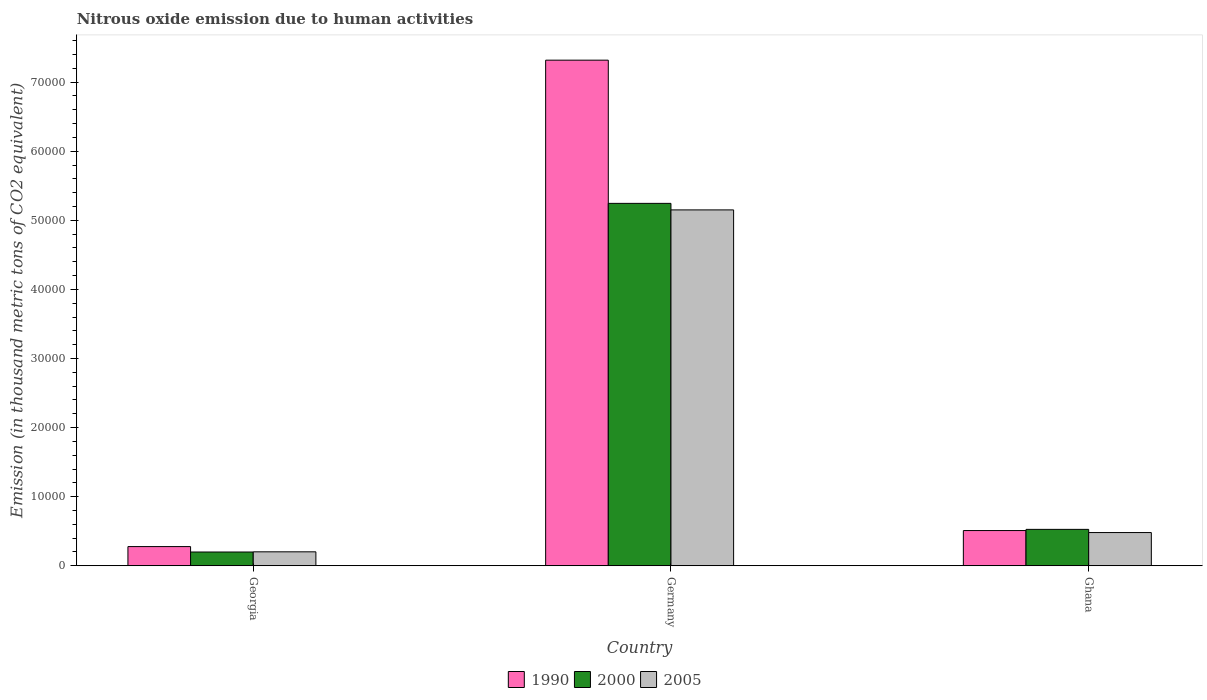How many different coloured bars are there?
Keep it short and to the point. 3. How many groups of bars are there?
Make the answer very short. 3. What is the label of the 1st group of bars from the left?
Your answer should be compact. Georgia. What is the amount of nitrous oxide emitted in 1990 in Germany?
Make the answer very short. 7.32e+04. Across all countries, what is the maximum amount of nitrous oxide emitted in 1990?
Provide a succinct answer. 7.32e+04. Across all countries, what is the minimum amount of nitrous oxide emitted in 2000?
Make the answer very short. 1994.5. In which country was the amount of nitrous oxide emitted in 2005 minimum?
Make the answer very short. Georgia. What is the total amount of nitrous oxide emitted in 2000 in the graph?
Offer a very short reply. 5.97e+04. What is the difference between the amount of nitrous oxide emitted in 1990 in Georgia and that in Germany?
Your response must be concise. -7.04e+04. What is the difference between the amount of nitrous oxide emitted in 2005 in Georgia and the amount of nitrous oxide emitted in 1990 in Germany?
Ensure brevity in your answer.  -7.12e+04. What is the average amount of nitrous oxide emitted in 1990 per country?
Offer a very short reply. 2.70e+04. What is the difference between the amount of nitrous oxide emitted of/in 2000 and amount of nitrous oxide emitted of/in 1990 in Ghana?
Offer a very short reply. 170. In how many countries, is the amount of nitrous oxide emitted in 2005 greater than 6000 thousand metric tons?
Offer a very short reply. 1. What is the ratio of the amount of nitrous oxide emitted in 2005 in Georgia to that in Ghana?
Your answer should be compact. 0.42. Is the amount of nitrous oxide emitted in 2005 in Georgia less than that in Ghana?
Offer a terse response. Yes. What is the difference between the highest and the second highest amount of nitrous oxide emitted in 2005?
Your answer should be compact. 4.67e+04. What is the difference between the highest and the lowest amount of nitrous oxide emitted in 2000?
Your response must be concise. 5.05e+04. Is the sum of the amount of nitrous oxide emitted in 2000 in Georgia and Ghana greater than the maximum amount of nitrous oxide emitted in 1990 across all countries?
Provide a succinct answer. No. What does the 1st bar from the right in Georgia represents?
Provide a succinct answer. 2005. Are all the bars in the graph horizontal?
Make the answer very short. No. Are the values on the major ticks of Y-axis written in scientific E-notation?
Your answer should be compact. No. Does the graph contain any zero values?
Offer a very short reply. No. Does the graph contain grids?
Keep it short and to the point. No. Where does the legend appear in the graph?
Provide a short and direct response. Bottom center. What is the title of the graph?
Give a very brief answer. Nitrous oxide emission due to human activities. What is the label or title of the X-axis?
Offer a very short reply. Country. What is the label or title of the Y-axis?
Your answer should be very brief. Emission (in thousand metric tons of CO2 equivalent). What is the Emission (in thousand metric tons of CO2 equivalent) in 1990 in Georgia?
Your answer should be compact. 2780.8. What is the Emission (in thousand metric tons of CO2 equivalent) of 2000 in Georgia?
Keep it short and to the point. 1994.5. What is the Emission (in thousand metric tons of CO2 equivalent) of 2005 in Georgia?
Provide a short and direct response. 2022. What is the Emission (in thousand metric tons of CO2 equivalent) of 1990 in Germany?
Your answer should be compact. 7.32e+04. What is the Emission (in thousand metric tons of CO2 equivalent) of 2000 in Germany?
Your answer should be compact. 5.25e+04. What is the Emission (in thousand metric tons of CO2 equivalent) in 2005 in Germany?
Offer a very short reply. 5.15e+04. What is the Emission (in thousand metric tons of CO2 equivalent) of 1990 in Ghana?
Your answer should be very brief. 5101.4. What is the Emission (in thousand metric tons of CO2 equivalent) in 2000 in Ghana?
Make the answer very short. 5271.4. What is the Emission (in thousand metric tons of CO2 equivalent) in 2005 in Ghana?
Give a very brief answer. 4812. Across all countries, what is the maximum Emission (in thousand metric tons of CO2 equivalent) of 1990?
Ensure brevity in your answer.  7.32e+04. Across all countries, what is the maximum Emission (in thousand metric tons of CO2 equivalent) in 2000?
Your response must be concise. 5.25e+04. Across all countries, what is the maximum Emission (in thousand metric tons of CO2 equivalent) of 2005?
Your answer should be very brief. 5.15e+04. Across all countries, what is the minimum Emission (in thousand metric tons of CO2 equivalent) in 1990?
Your response must be concise. 2780.8. Across all countries, what is the minimum Emission (in thousand metric tons of CO2 equivalent) in 2000?
Provide a succinct answer. 1994.5. Across all countries, what is the minimum Emission (in thousand metric tons of CO2 equivalent) of 2005?
Ensure brevity in your answer.  2022. What is the total Emission (in thousand metric tons of CO2 equivalent) of 1990 in the graph?
Provide a succinct answer. 8.11e+04. What is the total Emission (in thousand metric tons of CO2 equivalent) of 2000 in the graph?
Provide a short and direct response. 5.97e+04. What is the total Emission (in thousand metric tons of CO2 equivalent) of 2005 in the graph?
Your answer should be compact. 5.83e+04. What is the difference between the Emission (in thousand metric tons of CO2 equivalent) of 1990 in Georgia and that in Germany?
Keep it short and to the point. -7.04e+04. What is the difference between the Emission (in thousand metric tons of CO2 equivalent) in 2000 in Georgia and that in Germany?
Give a very brief answer. -5.05e+04. What is the difference between the Emission (in thousand metric tons of CO2 equivalent) in 2005 in Georgia and that in Germany?
Give a very brief answer. -4.95e+04. What is the difference between the Emission (in thousand metric tons of CO2 equivalent) in 1990 in Georgia and that in Ghana?
Ensure brevity in your answer.  -2320.6. What is the difference between the Emission (in thousand metric tons of CO2 equivalent) of 2000 in Georgia and that in Ghana?
Provide a short and direct response. -3276.9. What is the difference between the Emission (in thousand metric tons of CO2 equivalent) in 2005 in Georgia and that in Ghana?
Provide a short and direct response. -2790. What is the difference between the Emission (in thousand metric tons of CO2 equivalent) in 1990 in Germany and that in Ghana?
Provide a short and direct response. 6.81e+04. What is the difference between the Emission (in thousand metric tons of CO2 equivalent) in 2000 in Germany and that in Ghana?
Provide a short and direct response. 4.72e+04. What is the difference between the Emission (in thousand metric tons of CO2 equivalent) in 2005 in Germany and that in Ghana?
Offer a terse response. 4.67e+04. What is the difference between the Emission (in thousand metric tons of CO2 equivalent) of 1990 in Georgia and the Emission (in thousand metric tons of CO2 equivalent) of 2000 in Germany?
Keep it short and to the point. -4.97e+04. What is the difference between the Emission (in thousand metric tons of CO2 equivalent) in 1990 in Georgia and the Emission (in thousand metric tons of CO2 equivalent) in 2005 in Germany?
Your answer should be very brief. -4.87e+04. What is the difference between the Emission (in thousand metric tons of CO2 equivalent) of 2000 in Georgia and the Emission (in thousand metric tons of CO2 equivalent) of 2005 in Germany?
Provide a succinct answer. -4.95e+04. What is the difference between the Emission (in thousand metric tons of CO2 equivalent) in 1990 in Georgia and the Emission (in thousand metric tons of CO2 equivalent) in 2000 in Ghana?
Your response must be concise. -2490.6. What is the difference between the Emission (in thousand metric tons of CO2 equivalent) of 1990 in Georgia and the Emission (in thousand metric tons of CO2 equivalent) of 2005 in Ghana?
Offer a terse response. -2031.2. What is the difference between the Emission (in thousand metric tons of CO2 equivalent) in 2000 in Georgia and the Emission (in thousand metric tons of CO2 equivalent) in 2005 in Ghana?
Your answer should be compact. -2817.5. What is the difference between the Emission (in thousand metric tons of CO2 equivalent) in 1990 in Germany and the Emission (in thousand metric tons of CO2 equivalent) in 2000 in Ghana?
Your response must be concise. 6.79e+04. What is the difference between the Emission (in thousand metric tons of CO2 equivalent) in 1990 in Germany and the Emission (in thousand metric tons of CO2 equivalent) in 2005 in Ghana?
Make the answer very short. 6.84e+04. What is the difference between the Emission (in thousand metric tons of CO2 equivalent) in 2000 in Germany and the Emission (in thousand metric tons of CO2 equivalent) in 2005 in Ghana?
Your answer should be very brief. 4.76e+04. What is the average Emission (in thousand metric tons of CO2 equivalent) of 1990 per country?
Your answer should be compact. 2.70e+04. What is the average Emission (in thousand metric tons of CO2 equivalent) of 2000 per country?
Provide a short and direct response. 1.99e+04. What is the average Emission (in thousand metric tons of CO2 equivalent) of 2005 per country?
Give a very brief answer. 1.94e+04. What is the difference between the Emission (in thousand metric tons of CO2 equivalent) in 1990 and Emission (in thousand metric tons of CO2 equivalent) in 2000 in Georgia?
Offer a very short reply. 786.3. What is the difference between the Emission (in thousand metric tons of CO2 equivalent) in 1990 and Emission (in thousand metric tons of CO2 equivalent) in 2005 in Georgia?
Make the answer very short. 758.8. What is the difference between the Emission (in thousand metric tons of CO2 equivalent) of 2000 and Emission (in thousand metric tons of CO2 equivalent) of 2005 in Georgia?
Your answer should be very brief. -27.5. What is the difference between the Emission (in thousand metric tons of CO2 equivalent) in 1990 and Emission (in thousand metric tons of CO2 equivalent) in 2000 in Germany?
Offer a terse response. 2.07e+04. What is the difference between the Emission (in thousand metric tons of CO2 equivalent) in 1990 and Emission (in thousand metric tons of CO2 equivalent) in 2005 in Germany?
Provide a short and direct response. 2.17e+04. What is the difference between the Emission (in thousand metric tons of CO2 equivalent) in 2000 and Emission (in thousand metric tons of CO2 equivalent) in 2005 in Germany?
Make the answer very short. 945.2. What is the difference between the Emission (in thousand metric tons of CO2 equivalent) of 1990 and Emission (in thousand metric tons of CO2 equivalent) of 2000 in Ghana?
Ensure brevity in your answer.  -170. What is the difference between the Emission (in thousand metric tons of CO2 equivalent) of 1990 and Emission (in thousand metric tons of CO2 equivalent) of 2005 in Ghana?
Make the answer very short. 289.4. What is the difference between the Emission (in thousand metric tons of CO2 equivalent) in 2000 and Emission (in thousand metric tons of CO2 equivalent) in 2005 in Ghana?
Make the answer very short. 459.4. What is the ratio of the Emission (in thousand metric tons of CO2 equivalent) in 1990 in Georgia to that in Germany?
Offer a terse response. 0.04. What is the ratio of the Emission (in thousand metric tons of CO2 equivalent) in 2000 in Georgia to that in Germany?
Make the answer very short. 0.04. What is the ratio of the Emission (in thousand metric tons of CO2 equivalent) of 2005 in Georgia to that in Germany?
Provide a succinct answer. 0.04. What is the ratio of the Emission (in thousand metric tons of CO2 equivalent) of 1990 in Georgia to that in Ghana?
Your answer should be very brief. 0.55. What is the ratio of the Emission (in thousand metric tons of CO2 equivalent) of 2000 in Georgia to that in Ghana?
Keep it short and to the point. 0.38. What is the ratio of the Emission (in thousand metric tons of CO2 equivalent) of 2005 in Georgia to that in Ghana?
Your response must be concise. 0.42. What is the ratio of the Emission (in thousand metric tons of CO2 equivalent) of 1990 in Germany to that in Ghana?
Offer a terse response. 14.35. What is the ratio of the Emission (in thousand metric tons of CO2 equivalent) of 2000 in Germany to that in Ghana?
Give a very brief answer. 9.95. What is the ratio of the Emission (in thousand metric tons of CO2 equivalent) of 2005 in Germany to that in Ghana?
Ensure brevity in your answer.  10.71. What is the difference between the highest and the second highest Emission (in thousand metric tons of CO2 equivalent) of 1990?
Provide a succinct answer. 6.81e+04. What is the difference between the highest and the second highest Emission (in thousand metric tons of CO2 equivalent) of 2000?
Your answer should be compact. 4.72e+04. What is the difference between the highest and the second highest Emission (in thousand metric tons of CO2 equivalent) of 2005?
Make the answer very short. 4.67e+04. What is the difference between the highest and the lowest Emission (in thousand metric tons of CO2 equivalent) in 1990?
Make the answer very short. 7.04e+04. What is the difference between the highest and the lowest Emission (in thousand metric tons of CO2 equivalent) of 2000?
Provide a short and direct response. 5.05e+04. What is the difference between the highest and the lowest Emission (in thousand metric tons of CO2 equivalent) of 2005?
Your answer should be compact. 4.95e+04. 